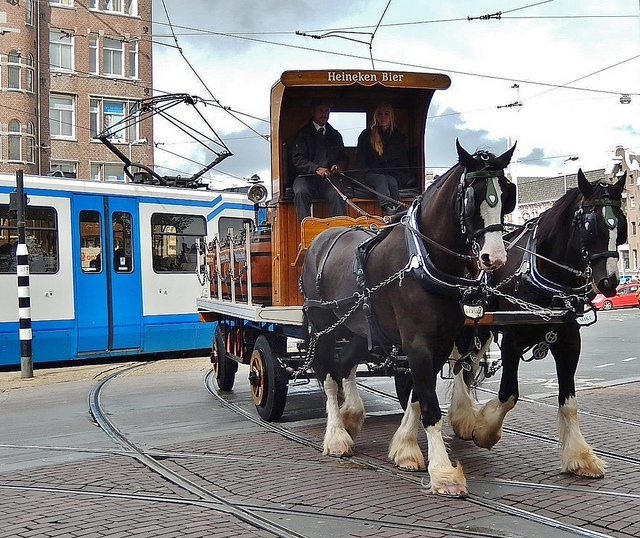Describe the objects in this image and their specific colors. I can see train in tan, lightgray, black, blue, and gray tones, horse in tan, black, gray, darkgray, and lightgray tones, horse in tan, black, darkgray, gray, and lightgray tones, people in tan, black, gray, and maroon tones, and people in tan, black, maroon, and gray tones in this image. 